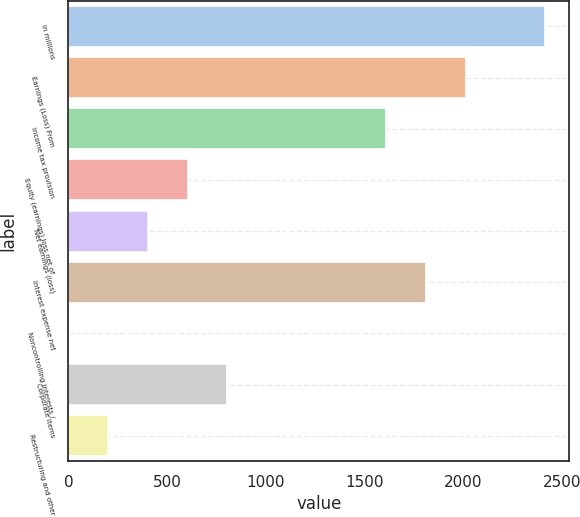Convert chart to OTSL. <chart><loc_0><loc_0><loc_500><loc_500><bar_chart><fcel>In millions<fcel>Earnings (Loss) From<fcel>Income tax provision<fcel>Equity (earnings) loss net of<fcel>Net earnings (loss)<fcel>Interest expense net<fcel>Noncontrolling interests /<fcel>Corporate items<fcel>Restructuring and other<nl><fcel>2415.4<fcel>2013<fcel>1610.6<fcel>604.6<fcel>403.4<fcel>1811.8<fcel>1<fcel>805.8<fcel>202.2<nl></chart> 